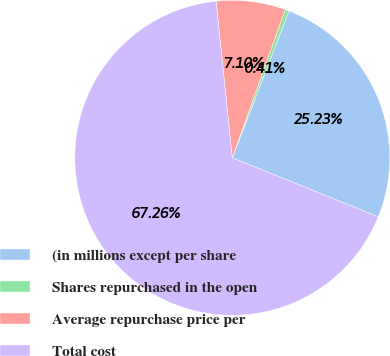Convert chart to OTSL. <chart><loc_0><loc_0><loc_500><loc_500><pie_chart><fcel>(in millions except per share<fcel>Shares repurchased in the open<fcel>Average repurchase price per<fcel>Total cost<nl><fcel>25.23%<fcel>0.41%<fcel>7.1%<fcel>67.25%<nl></chart> 